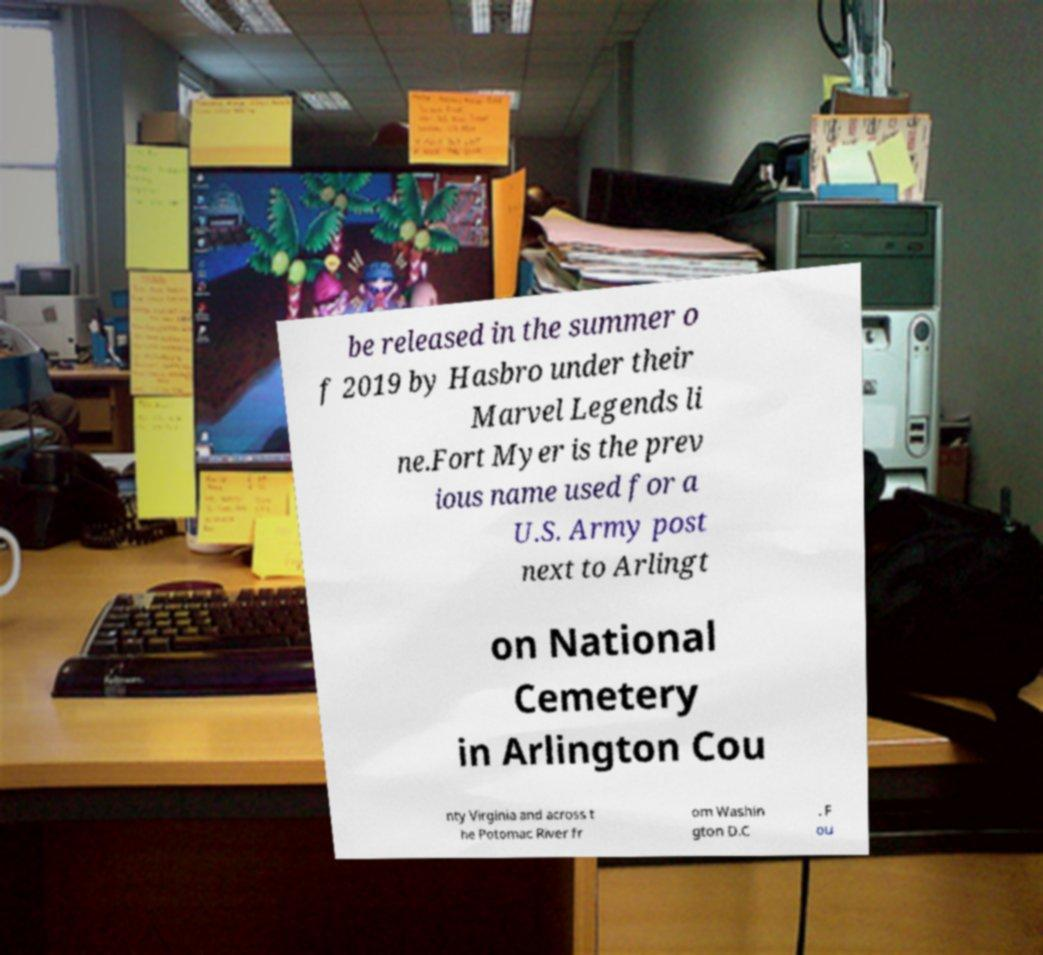Can you read and provide the text displayed in the image?This photo seems to have some interesting text. Can you extract and type it out for me? be released in the summer o f 2019 by Hasbro under their Marvel Legends li ne.Fort Myer is the prev ious name used for a U.S. Army post next to Arlingt on National Cemetery in Arlington Cou nty Virginia and across t he Potomac River fr om Washin gton D.C . F ou 